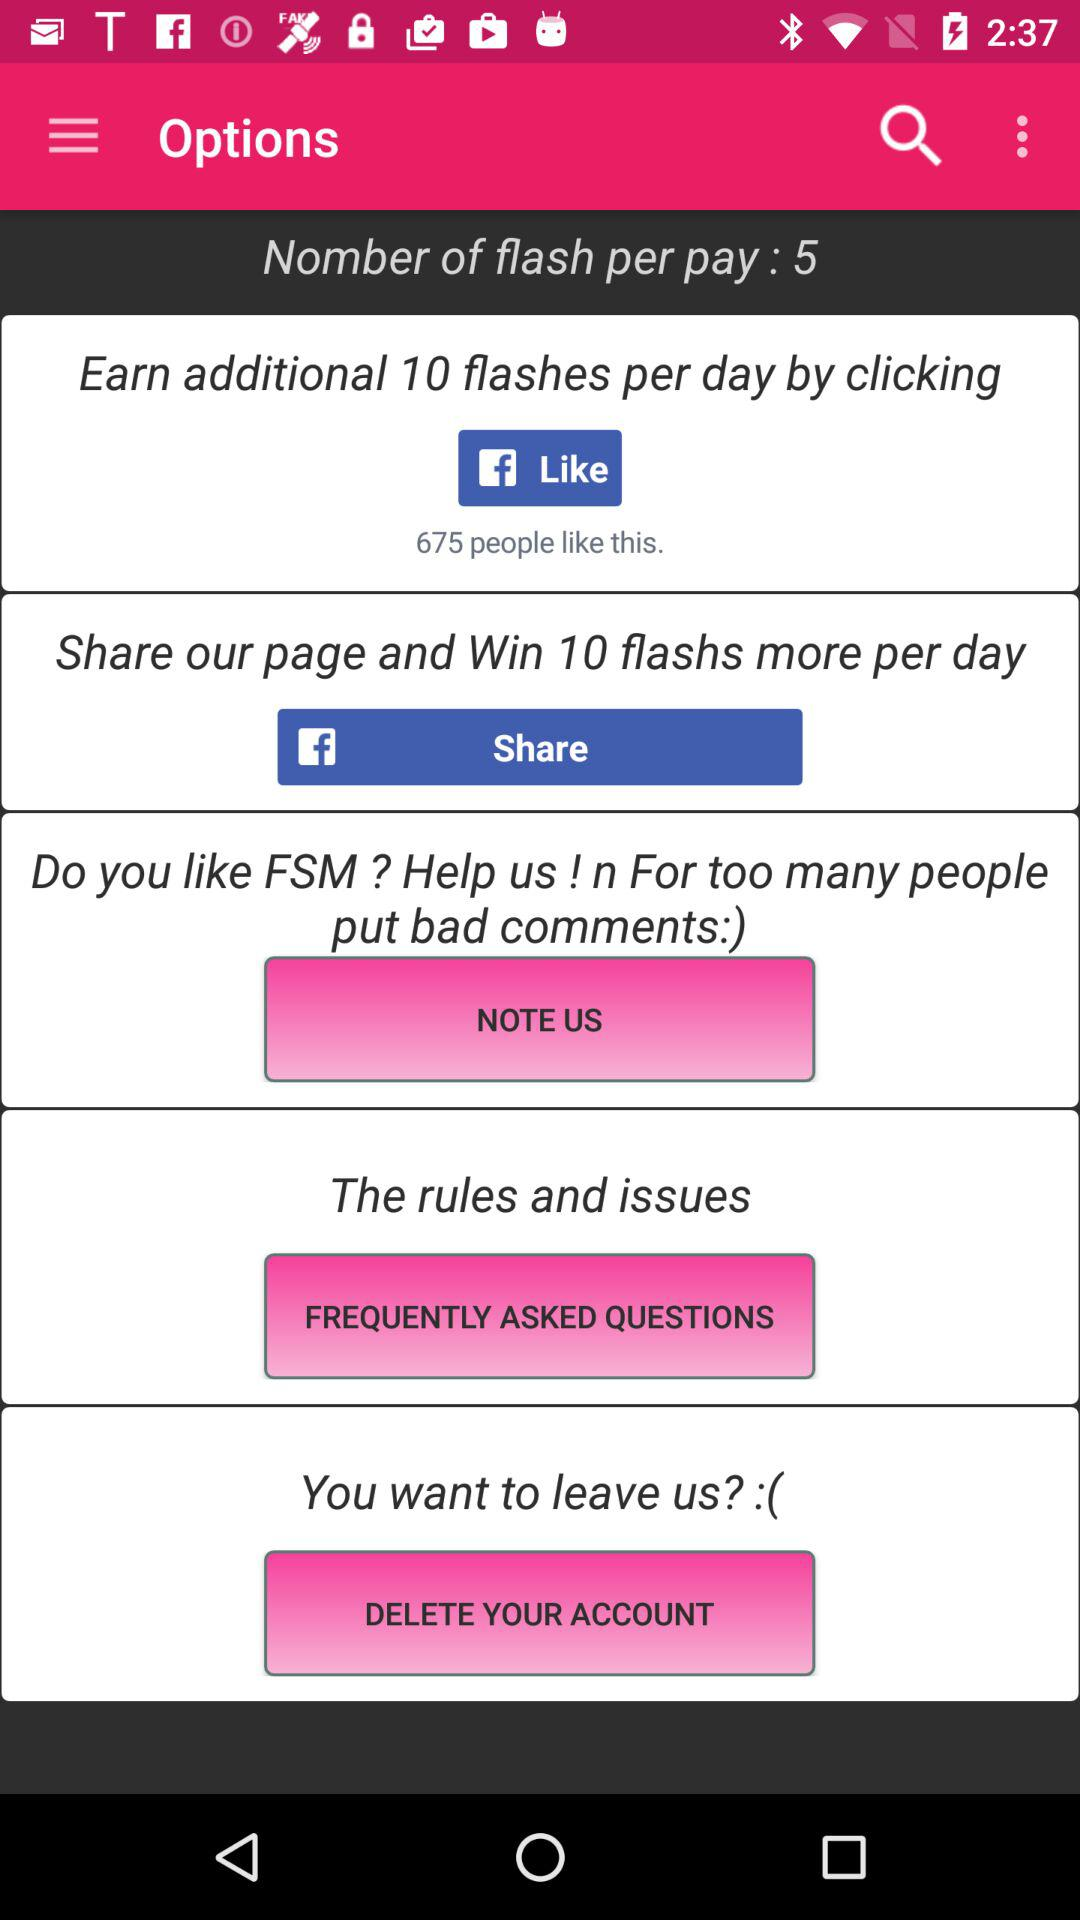What's the count of flashes per pay? The count of flashes per pay is 5. 